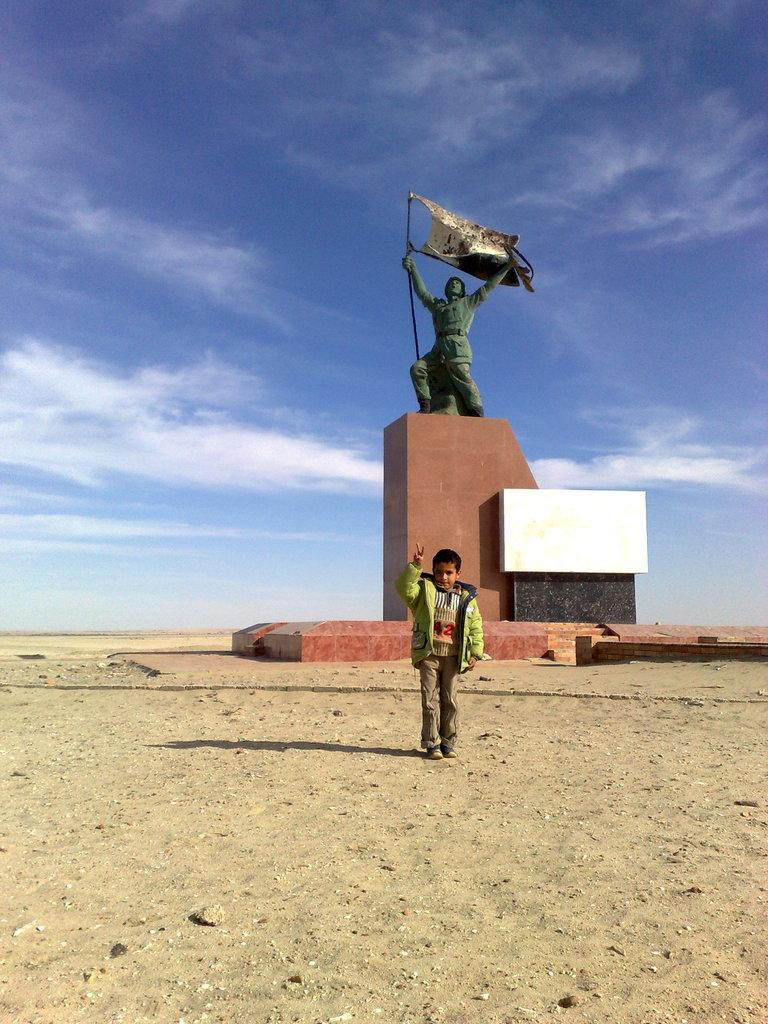Who is the main subject in the image? There is a man standing in the center of the image. What can be seen in the background of the image? There is a statue in the background of the image. What is the statue standing on? There is a pedestal associated with the statue. What is visible at the top of the image? The sky is visible at the top of the image. What type of cord is being used by the man in the image? There is no cord visible in the image; the man is simply standing in the center. 